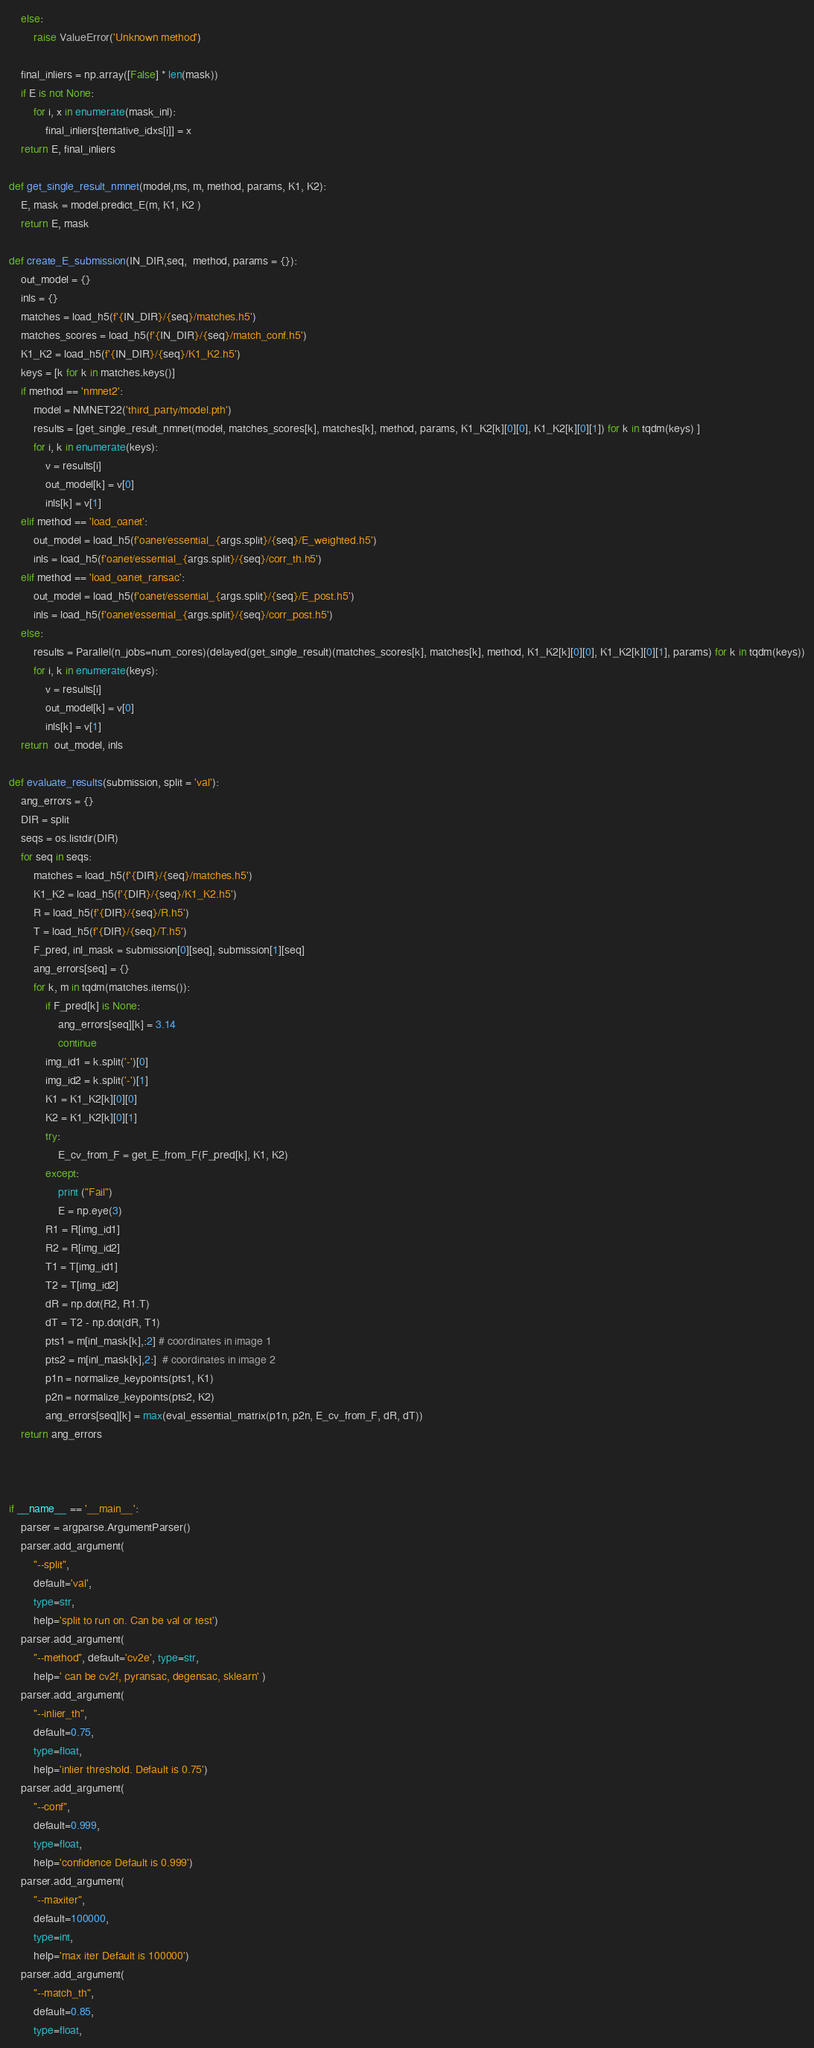Convert code to text. <code><loc_0><loc_0><loc_500><loc_500><_Python_>    else:
        raise ValueError('Unknown method')
    
    final_inliers = np.array([False] * len(mask))
    if E is not None:
        for i, x in enumerate(mask_inl):
            final_inliers[tentative_idxs[i]] = x
    return E, final_inliers

def get_single_result_nmnet(model,ms, m, method, params, K1, K2):
    E, mask = model.predict_E(m, K1, K2 )
    return E, mask
        
def create_E_submission(IN_DIR,seq,  method, params = {}):
    out_model = {}
    inls = {}
    matches = load_h5(f'{IN_DIR}/{seq}/matches.h5')
    matches_scores = load_h5(f'{IN_DIR}/{seq}/match_conf.h5')
    K1_K2 = load_h5(f'{IN_DIR}/{seq}/K1_K2.h5')
    keys = [k for k in matches.keys()]
    if method == 'nmnet2':
        model = NMNET22('third_party/model.pth')
        results = [get_single_result_nmnet(model, matches_scores[k], matches[k], method, params, K1_K2[k][0][0], K1_K2[k][0][1]) for k in tqdm(keys) ]
        for i, k in enumerate(keys):
            v = results[i]
            out_model[k] = v[0]
            inls[k] = v[1]
    elif method == 'load_oanet':
        out_model = load_h5(f'oanet/essential_{args.split}/{seq}/E_weighted.h5')
        inls = load_h5(f'oanet/essential_{args.split}/{seq}/corr_th.h5')
    elif method == 'load_oanet_ransac':
        out_model = load_h5(f'oanet/essential_{args.split}/{seq}/E_post.h5')
        inls = load_h5(f'oanet/essential_{args.split}/{seq}/corr_post.h5')
    else:
        results = Parallel(n_jobs=num_cores)(delayed(get_single_result)(matches_scores[k], matches[k], method, K1_K2[k][0][0], K1_K2[k][0][1], params) for k in tqdm(keys))
        for i, k in enumerate(keys):
            v = results[i]
            out_model[k] = v[0]
            inls[k] = v[1]
    return  out_model, inls

def evaluate_results(submission, split = 'val'):
    ang_errors = {}
    DIR = split
    seqs = os.listdir(DIR)
    for seq in seqs:
        matches = load_h5(f'{DIR}/{seq}/matches.h5')
        K1_K2 = load_h5(f'{DIR}/{seq}/K1_K2.h5')
        R = load_h5(f'{DIR}/{seq}/R.h5')
        T = load_h5(f'{DIR}/{seq}/T.h5')
        F_pred, inl_mask = submission[0][seq], submission[1][seq]
        ang_errors[seq] = {}
        for k, m in tqdm(matches.items()):
            if F_pred[k] is None:
                ang_errors[seq][k] = 3.14
                continue
            img_id1 = k.split('-')[0]
            img_id2 = k.split('-')[1]
            K1 = K1_K2[k][0][0]
            K2 = K1_K2[k][0][1]
            try:
                E_cv_from_F = get_E_from_F(F_pred[k], K1, K2)
            except:
                print ("Fail")
                E = np.eye(3)
            R1 = R[img_id1]
            R2 = R[img_id2]
            T1 = T[img_id1]
            T2 = T[img_id2]
            dR = np.dot(R2, R1.T)
            dT = T2 - np.dot(dR, T1)
            pts1 = m[inl_mask[k],:2] # coordinates in image 1
            pts2 = m[inl_mask[k],2:]  # coordinates in image 2
            p1n = normalize_keypoints(pts1, K1)
            p2n = normalize_keypoints(pts2, K2)
            ang_errors[seq][k] = max(eval_essential_matrix(p1n, p2n, E_cv_from_F, dR, dT))
    return ang_errors



if __name__ == '__main__':
    parser = argparse.ArgumentParser()
    parser.add_argument(
        "--split",
        default='val',
        type=str,
        help='split to run on. Can be val or test')
    parser.add_argument(
        "--method", default='cv2e', type=str,
        help=' can be cv2f, pyransac, degensac, sklearn' )
    parser.add_argument(
        "--inlier_th",
        default=0.75,
        type=float,
        help='inlier threshold. Default is 0.75')
    parser.add_argument(
        "--conf",
        default=0.999,
        type=float,
        help='confidence Default is 0.999')
    parser.add_argument(
        "--maxiter",
        default=100000,
        type=int,
        help='max iter Default is 100000')
    parser.add_argument(
        "--match_th",
        default=0.85,
        type=float,</code> 